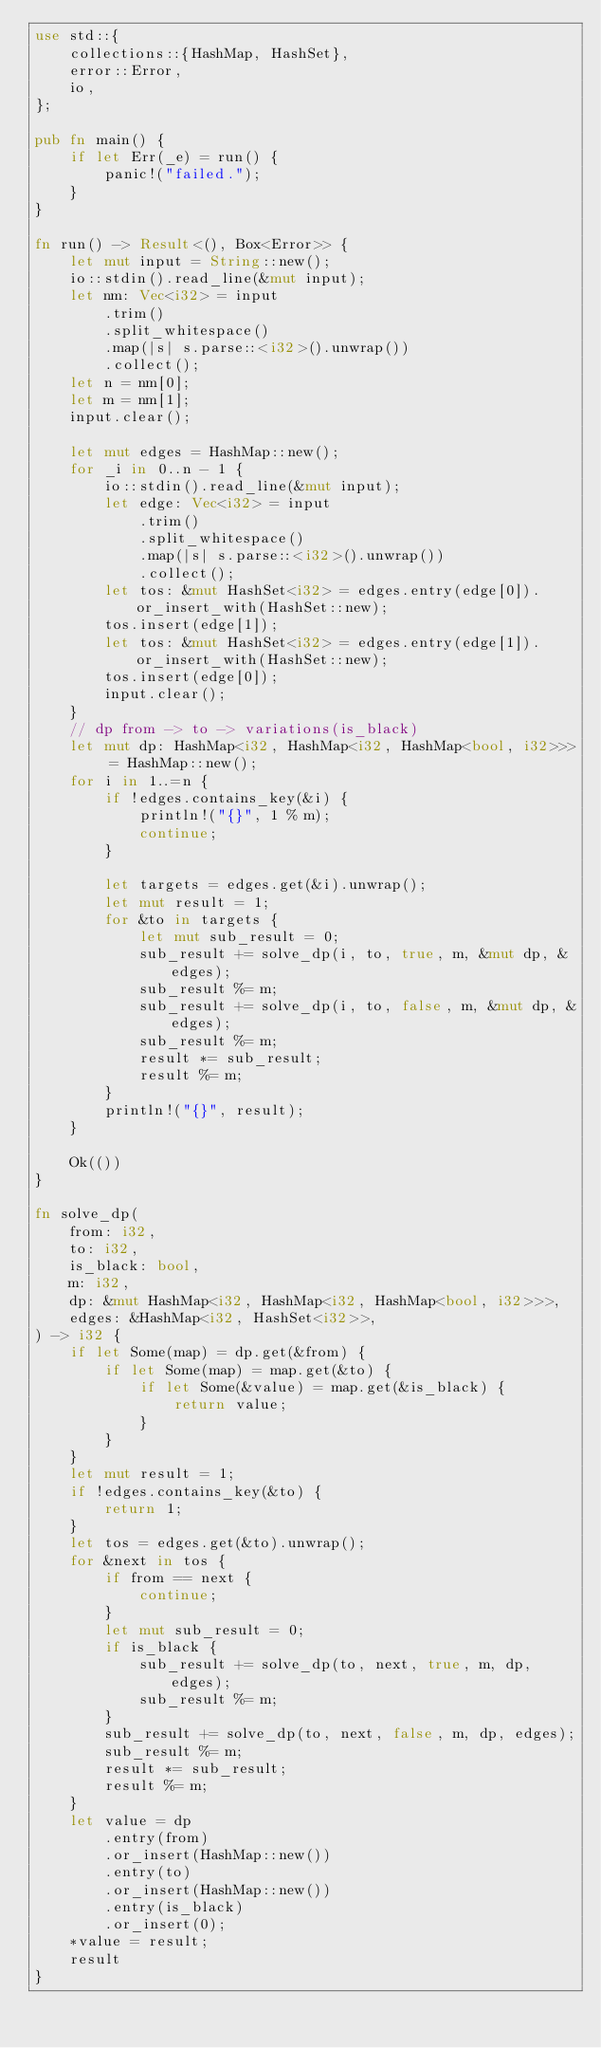<code> <loc_0><loc_0><loc_500><loc_500><_Rust_>use std::{
    collections::{HashMap, HashSet},
    error::Error,
    io,
};

pub fn main() {
    if let Err(_e) = run() {
        panic!("failed.");
    }
}

fn run() -> Result<(), Box<Error>> {
    let mut input = String::new();
    io::stdin().read_line(&mut input);
    let nm: Vec<i32> = input
        .trim()
        .split_whitespace()
        .map(|s| s.parse::<i32>().unwrap())
        .collect();
    let n = nm[0];
    let m = nm[1];
    input.clear();

    let mut edges = HashMap::new();
    for _i in 0..n - 1 {
        io::stdin().read_line(&mut input);
        let edge: Vec<i32> = input
            .trim()
            .split_whitespace()
            .map(|s| s.parse::<i32>().unwrap())
            .collect();
        let tos: &mut HashSet<i32> = edges.entry(edge[0]).or_insert_with(HashSet::new);
        tos.insert(edge[1]);
        let tos: &mut HashSet<i32> = edges.entry(edge[1]).or_insert_with(HashSet::new);
        tos.insert(edge[0]);
        input.clear();
    }
    // dp from -> to -> variations(is_black)
    let mut dp: HashMap<i32, HashMap<i32, HashMap<bool, i32>>> = HashMap::new();
    for i in 1..=n {
        if !edges.contains_key(&i) {
            println!("{}", 1 % m);
            continue;
        }

        let targets = edges.get(&i).unwrap();
        let mut result = 1;
        for &to in targets {
            let mut sub_result = 0;
            sub_result += solve_dp(i, to, true, m, &mut dp, &edges);
            sub_result %= m;
            sub_result += solve_dp(i, to, false, m, &mut dp, &edges);
            sub_result %= m;
            result *= sub_result;
            result %= m;
        }
        println!("{}", result);
    }

    Ok(())
}

fn solve_dp(
    from: i32,
    to: i32,
    is_black: bool,
    m: i32,
    dp: &mut HashMap<i32, HashMap<i32, HashMap<bool, i32>>>,
    edges: &HashMap<i32, HashSet<i32>>,
) -> i32 {
    if let Some(map) = dp.get(&from) {
        if let Some(map) = map.get(&to) {
            if let Some(&value) = map.get(&is_black) {
                return value;
            }
        }
    }
    let mut result = 1;
    if !edges.contains_key(&to) {
        return 1;
    }
    let tos = edges.get(&to).unwrap();
    for &next in tos {
        if from == next {
            continue;
        }
        let mut sub_result = 0;
        if is_black {
            sub_result += solve_dp(to, next, true, m, dp, edges);
            sub_result %= m;
        }
        sub_result += solve_dp(to, next, false, m, dp, edges);
        sub_result %= m;
        result *= sub_result;
        result %= m;
    }
    let value = dp
        .entry(from)
        .or_insert(HashMap::new())
        .entry(to)
        .or_insert(HashMap::new())
        .entry(is_black)
        .or_insert(0);
    *value = result;
    result
}
</code> 